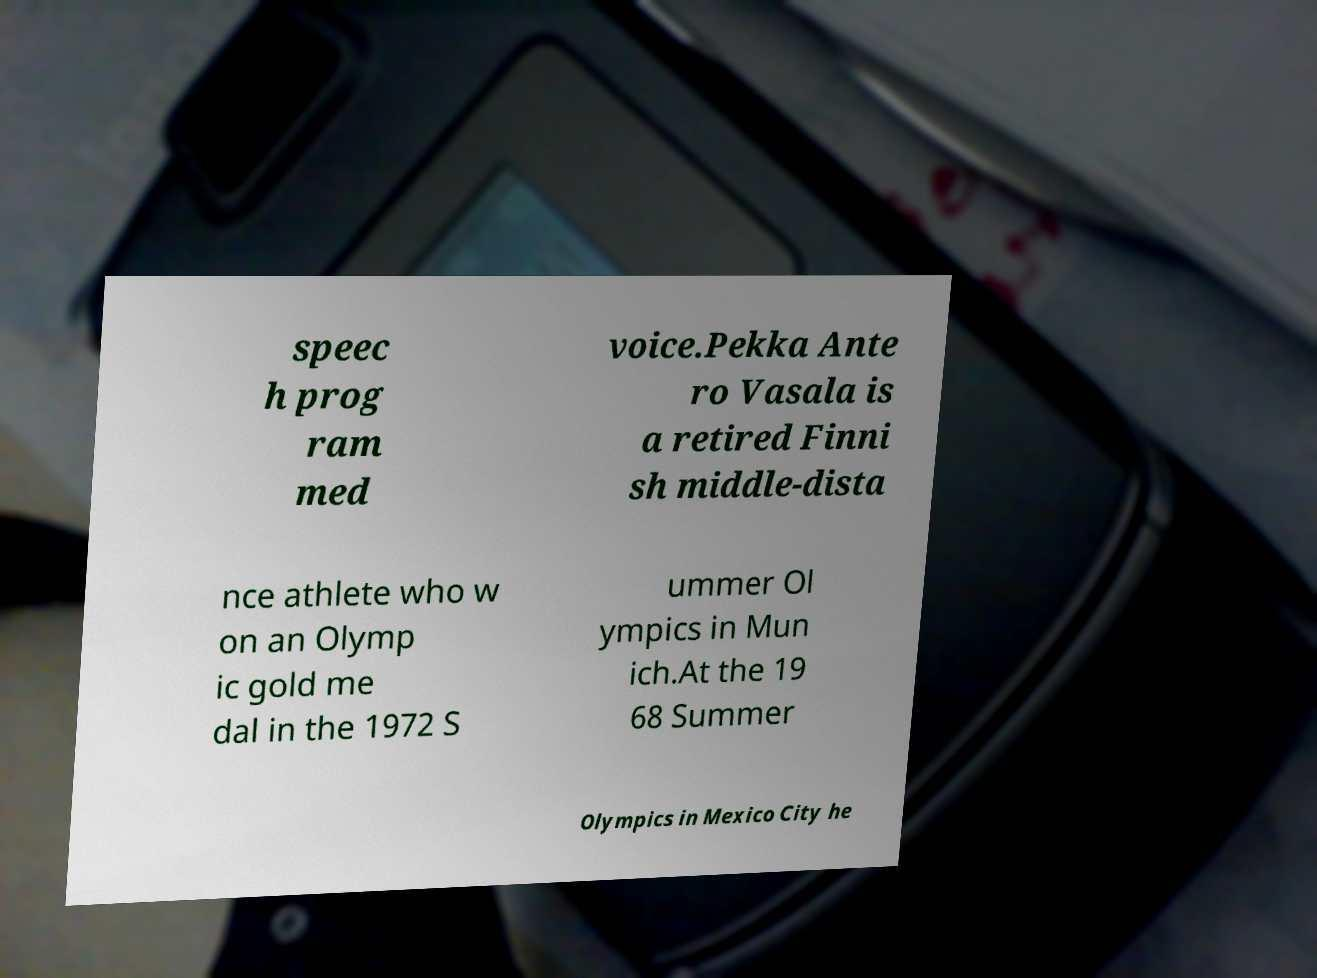I need the written content from this picture converted into text. Can you do that? speec h prog ram med voice.Pekka Ante ro Vasala is a retired Finni sh middle-dista nce athlete who w on an Olymp ic gold me dal in the 1972 S ummer Ol ympics in Mun ich.At the 19 68 Summer Olympics in Mexico City he 